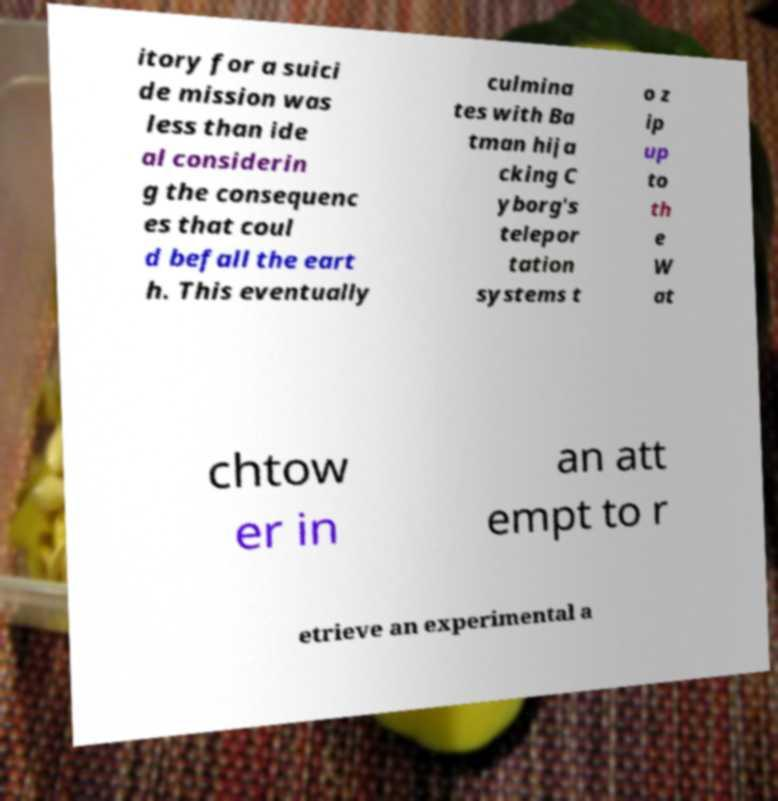Could you assist in decoding the text presented in this image and type it out clearly? itory for a suici de mission was less than ide al considerin g the consequenc es that coul d befall the eart h. This eventually culmina tes with Ba tman hija cking C yborg's telepor tation systems t o z ip up to th e W at chtow er in an att empt to r etrieve an experimental a 